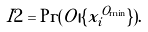Convert formula to latex. <formula><loc_0><loc_0><loc_500><loc_500>I 2 = \Pr ( O | \{ x _ { i } ^ { O _ { \min } } \} ) .</formula> 